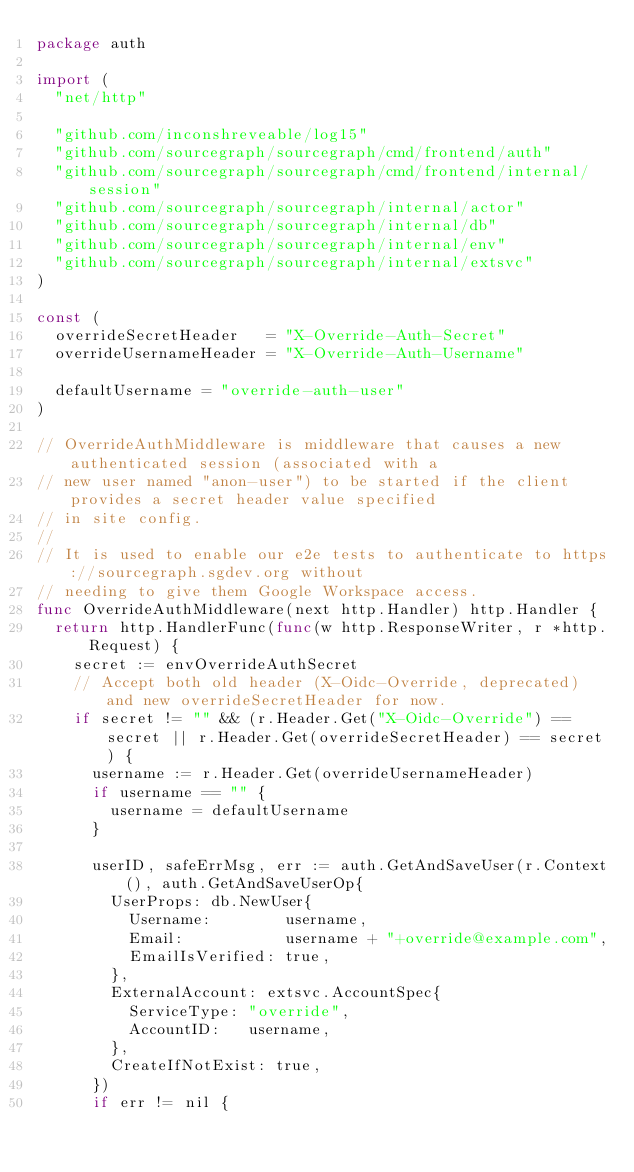Convert code to text. <code><loc_0><loc_0><loc_500><loc_500><_Go_>package auth

import (
	"net/http"

	"github.com/inconshreveable/log15"
	"github.com/sourcegraph/sourcegraph/cmd/frontend/auth"
	"github.com/sourcegraph/sourcegraph/cmd/frontend/internal/session"
	"github.com/sourcegraph/sourcegraph/internal/actor"
	"github.com/sourcegraph/sourcegraph/internal/db"
	"github.com/sourcegraph/sourcegraph/internal/env"
	"github.com/sourcegraph/sourcegraph/internal/extsvc"
)

const (
	overrideSecretHeader   = "X-Override-Auth-Secret"
	overrideUsernameHeader = "X-Override-Auth-Username"

	defaultUsername = "override-auth-user"
)

// OverrideAuthMiddleware is middleware that causes a new authenticated session (associated with a
// new user named "anon-user") to be started if the client provides a secret header value specified
// in site config.
//
// It is used to enable our e2e tests to authenticate to https://sourcegraph.sgdev.org without
// needing to give them Google Workspace access.
func OverrideAuthMiddleware(next http.Handler) http.Handler {
	return http.HandlerFunc(func(w http.ResponseWriter, r *http.Request) {
		secret := envOverrideAuthSecret
		// Accept both old header (X-Oidc-Override, deprecated) and new overrideSecretHeader for now.
		if secret != "" && (r.Header.Get("X-Oidc-Override") == secret || r.Header.Get(overrideSecretHeader) == secret) {
			username := r.Header.Get(overrideUsernameHeader)
			if username == "" {
				username = defaultUsername
			}

			userID, safeErrMsg, err := auth.GetAndSaveUser(r.Context(), auth.GetAndSaveUserOp{
				UserProps: db.NewUser{
					Username:        username,
					Email:           username + "+override@example.com",
					EmailIsVerified: true,
				},
				ExternalAccount: extsvc.AccountSpec{
					ServiceType: "override",
					AccountID:   username,
				},
				CreateIfNotExist: true,
			})
			if err != nil {</code> 